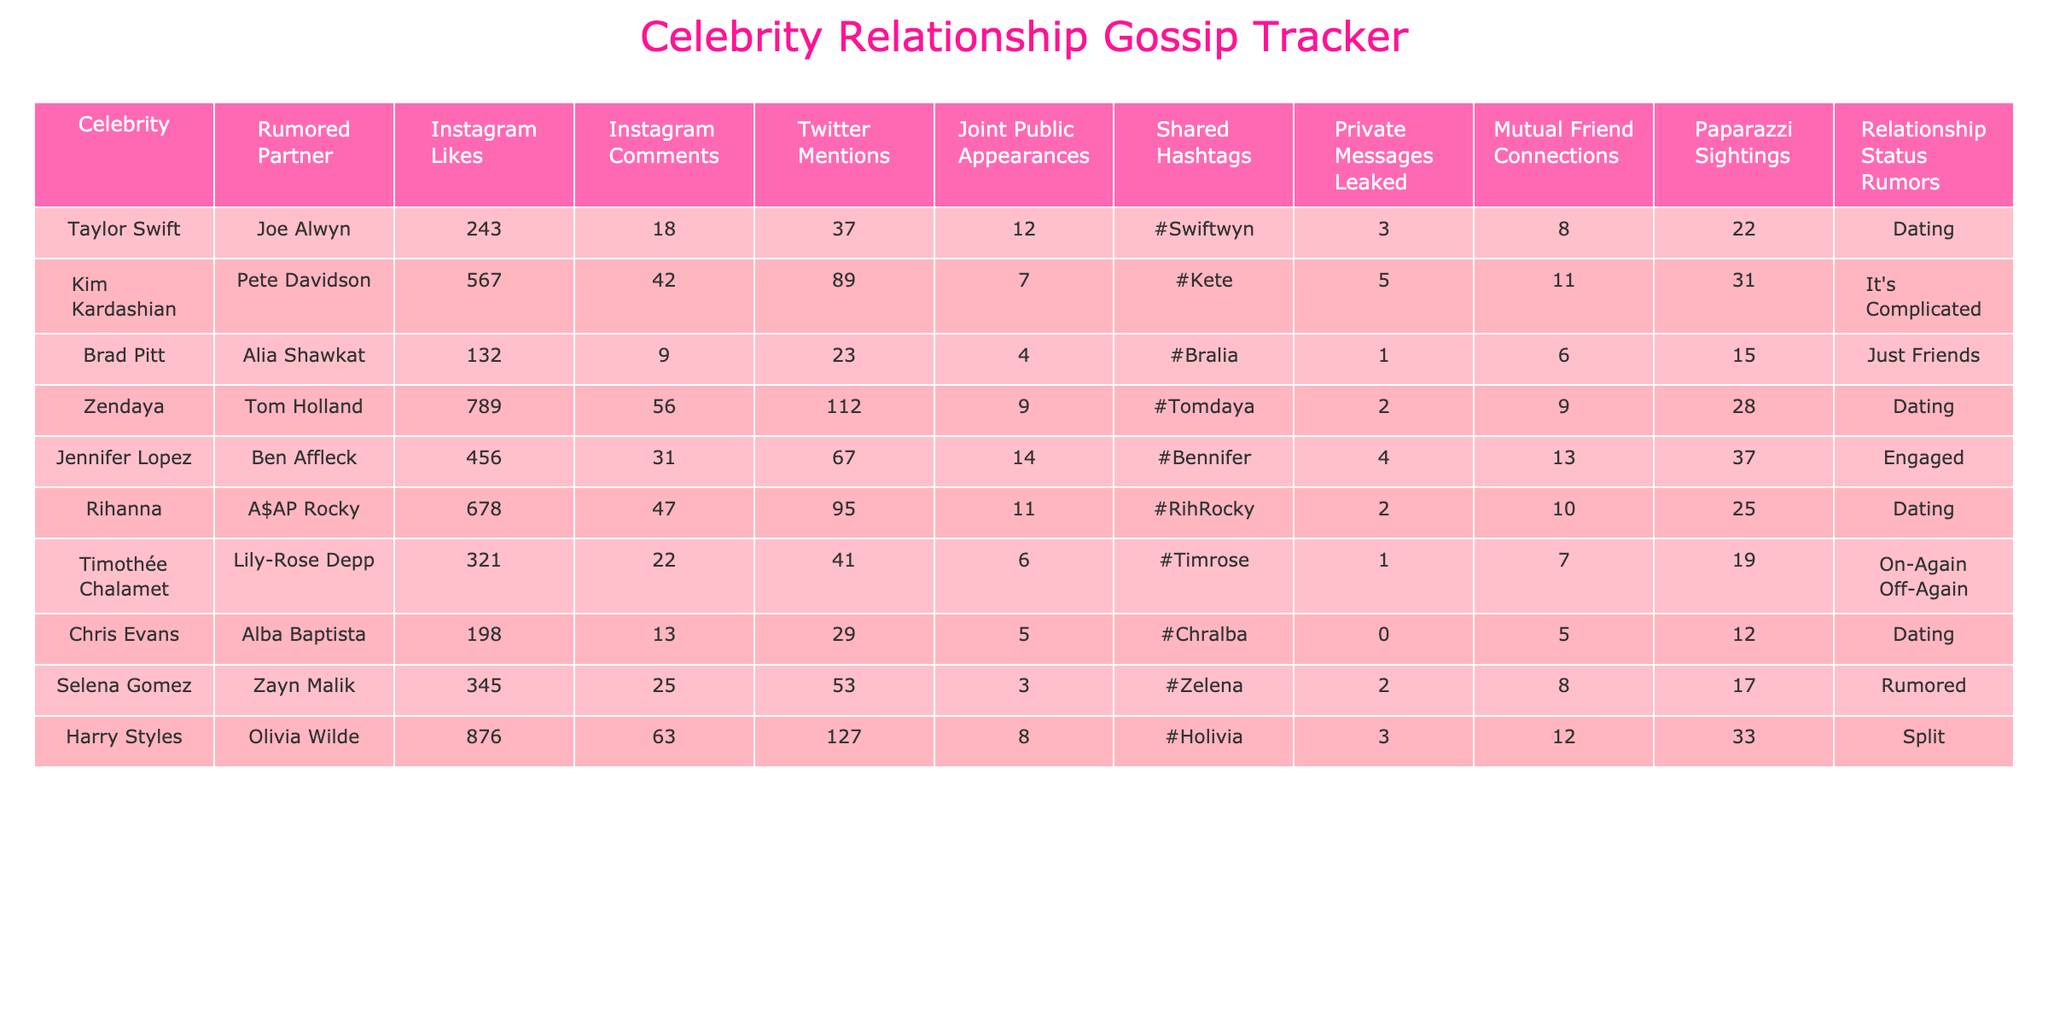What's the total number of Instagram likes for all celebrities in the table? To find the total, we need to add up the Instagram likes for each celebrity: 243 + 567 + 132 + 789 + 456 + 678 + 321 + 198 + 345 + 876 = 3364.
Answer: 3364 Which celebrity has the highest number of Twitter mentions? By checking each row, we find that Harry Styles has the highest Twitter mentions with 127.
Answer: Harry Styles How many joint public appearances have Taylor Swift and Joe Alwyn made? The table shows that Taylor Swift and Joe Alwyn have made 12 joint public appearances together.
Answer: 12 Is it true that Kim Kardashian and Pete Davidson have more Instagram likes than Zendaya and Tom Holland? Comparing the likes, Kim Kardashian has 567 and Zendaya has 789, so it is false as Zendaya has more likes.
Answer: False What is the average number of Instagram comments across all relationships listed? The average is calculated by adding the Instagram comments (18 + 42 + 9 + 56 + 31 + 47 + 22 + 13 + 25 + 63 = 306) and dividing by the number of relationships (10): 306 / 10 = 30.6.
Answer: 30.6 How many celebrities in the table are currently dating their rumored partners? Counting the rows marked as "Dating," we see that Taylor Swift, Zendaya, Rihanna, and Chris Evans are dating, totaling 4 celebrities.
Answer: 4 Which relationship has the most mutual friend connections? Comparing the mutual friend connections, Jennifer Lopez and Ben Affleck have the highest at 13 connections, which is more than any other couple.
Answer: Jennifer Lopez and Ben Affleck What percentage of the celebrities in the table are rumored to be engaged? Out of 10 celebrities, only Jennifer Lopez and Ben Affleck are engaged, which is 1 out of 10, resulting in 10%.
Answer: 10% How many paparazzi sightings did Harry Styles and Olivia Wilde have compared to Taylor Swift and Joe Alwyn? Harry Styles and Olivia Wilde had 33 sightings, while Taylor Swift and Joe Alwyn had 22 sightings. The difference is 33 - 22 = 11.
Answer: 11 Which couple has had the least private messages leaked, and how many were leaked? The couple with the least leaked private messages is Chris Evans and Alba Baptista, with 0 messages leaked.
Answer: 0 